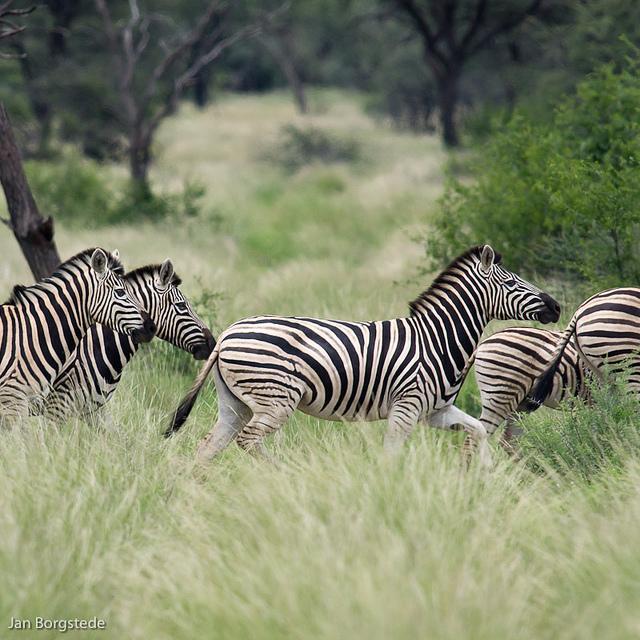How many zebra heads can you see?
Give a very brief answer. 3. How many zebras are there?
Give a very brief answer. 5. 